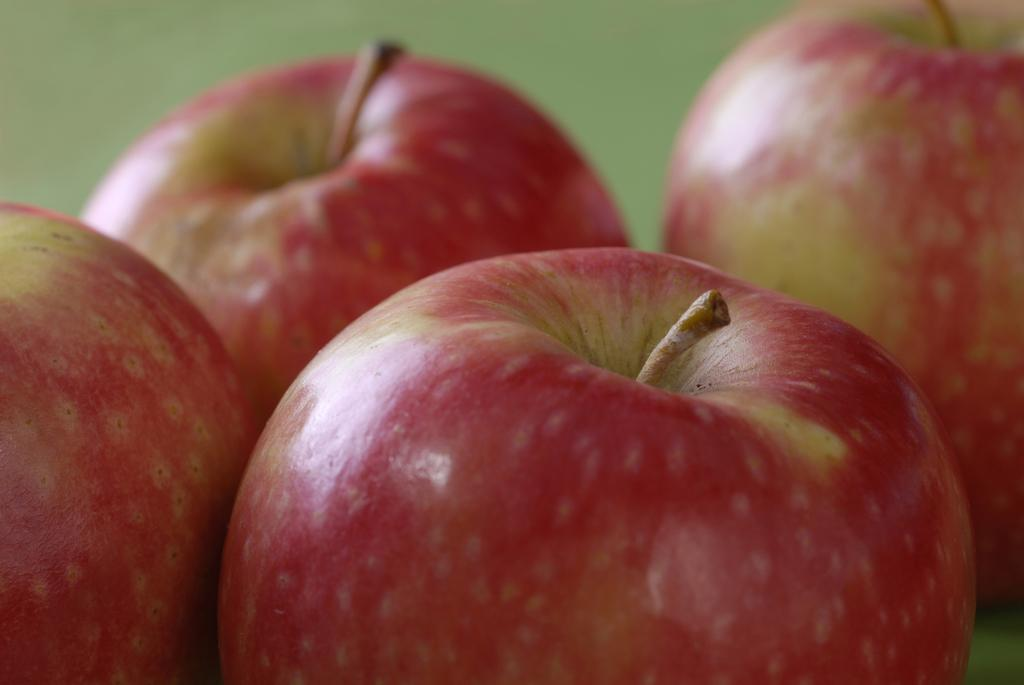What type of food can be seen in the image? There are fruits in the image. Can you describe the background of the image? The background of the image is blurred. What is the price of the egg in the image? There is no egg present in the image, so it is not possible to determine its price. 